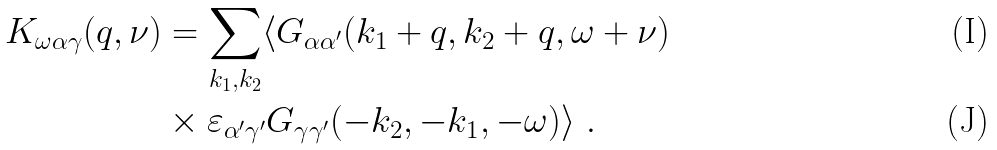<formula> <loc_0><loc_0><loc_500><loc_500>K _ { \omega \alpha \gamma } ( { q } , \nu ) & = \sum _ { { k } _ { 1 } , { k } _ { 2 } } \langle G _ { \alpha \alpha ^ { \prime } } ( { k } _ { 1 } + { q } , { k } _ { 2 } + { q } , \omega + \nu ) \\ & \times \varepsilon _ { \alpha ^ { \prime } \gamma ^ { \prime } } G _ { \gamma \gamma ^ { \prime } } ( - { k } _ { 2 } , - { k } _ { 1 } , - \omega ) \rangle \ .</formula> 